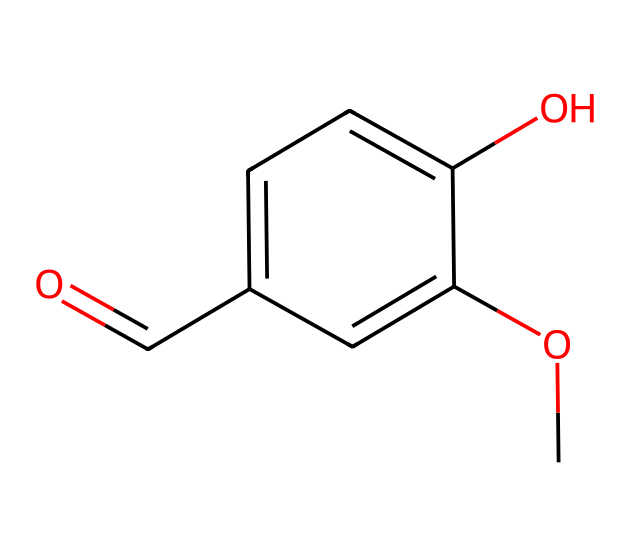How many carbon atoms are in the structure? The SMILES representation COc1cc(C=O)ccc1O indicates that there are six carbon atoms total: one in the methoxy group (CO), four in the phenyl ring (c1ccccc1), and one in the aldehyde group (C=O).
Answer: six What functional groups are present in this compound? The chemical structure includes a methoxy group (–OCH3), an aldehyde group (–CHO), and a hydroxyl group (–OH). These clearly indicated groups are identifiable in the SMILES notation.
Answer: methoxy, aldehyde, hydroxyl What type of compound is vanillin categorized as? Vanillin, represented by COc1cc(C=O)ccc1O, falls into the category of aromatic aldehydes due to its aromatic ring and the presence of the aldehyde functional group.
Answer: aromatic aldehyde Which part of the structure indicates it is an aldehyde? The aldehyde functional group is indicated by the presence of the carbonyl group (C=O) attached to a carbon atom, specifically indicated in the notation as C=O. This key structural feature identifies the compound's classification.
Answer: carbonyl group How many rings are present in the molecular structure? The structure contains one aromatic ring, denoted as c1ccccc1 in the SMILES notation. The 'c' indicates it's part of a cyclic aromatic system, showing that there’s only one ring present.
Answer: one What is the degree of saturation of this compound? The degree of saturation can be determined by considering the number of rings and multiple bonds. The presence of one double bond from the aldehyde and one aromatic ring suggests a degree of saturation of five, calculated using the formula for unsaturation which accounts for double bonds and rings.
Answer: five 